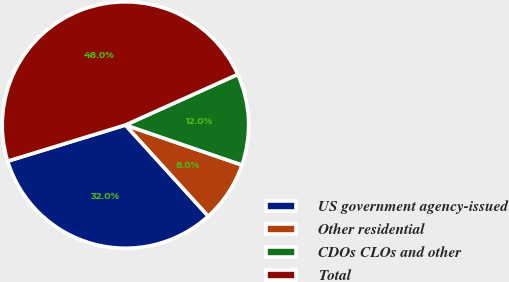Convert chart. <chart><loc_0><loc_0><loc_500><loc_500><pie_chart><fcel>US government agency-issued<fcel>Other residential<fcel>CDOs CLOs and other<fcel>Total<nl><fcel>32.0%<fcel>8.0%<fcel>12.0%<fcel>48.0%<nl></chart> 